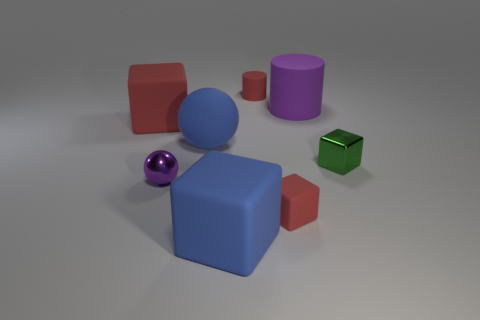Is the number of tiny green metal blocks to the left of the blue sphere greater than the number of big balls that are in front of the small green thing?
Make the answer very short. No. There is a purple metal sphere; are there any big purple cylinders to the right of it?
Your response must be concise. Yes. Are there any rubber blocks of the same size as the green object?
Your response must be concise. Yes. There is a small cube that is the same material as the small sphere; what color is it?
Provide a short and direct response. Green. What is the material of the red cylinder?
Your answer should be compact. Rubber. The tiny purple object is what shape?
Keep it short and to the point. Sphere. What number of cylinders are the same color as the small matte cube?
Your answer should be very brief. 1. The object on the right side of the purple object that is to the right of the red matte cube that is in front of the large red block is made of what material?
Provide a succinct answer. Metal. What number of red objects are big matte cylinders or cylinders?
Your response must be concise. 1. There is a red thing that is in front of the small metallic object on the right side of the red matte object in front of the big red object; what size is it?
Keep it short and to the point. Small. 